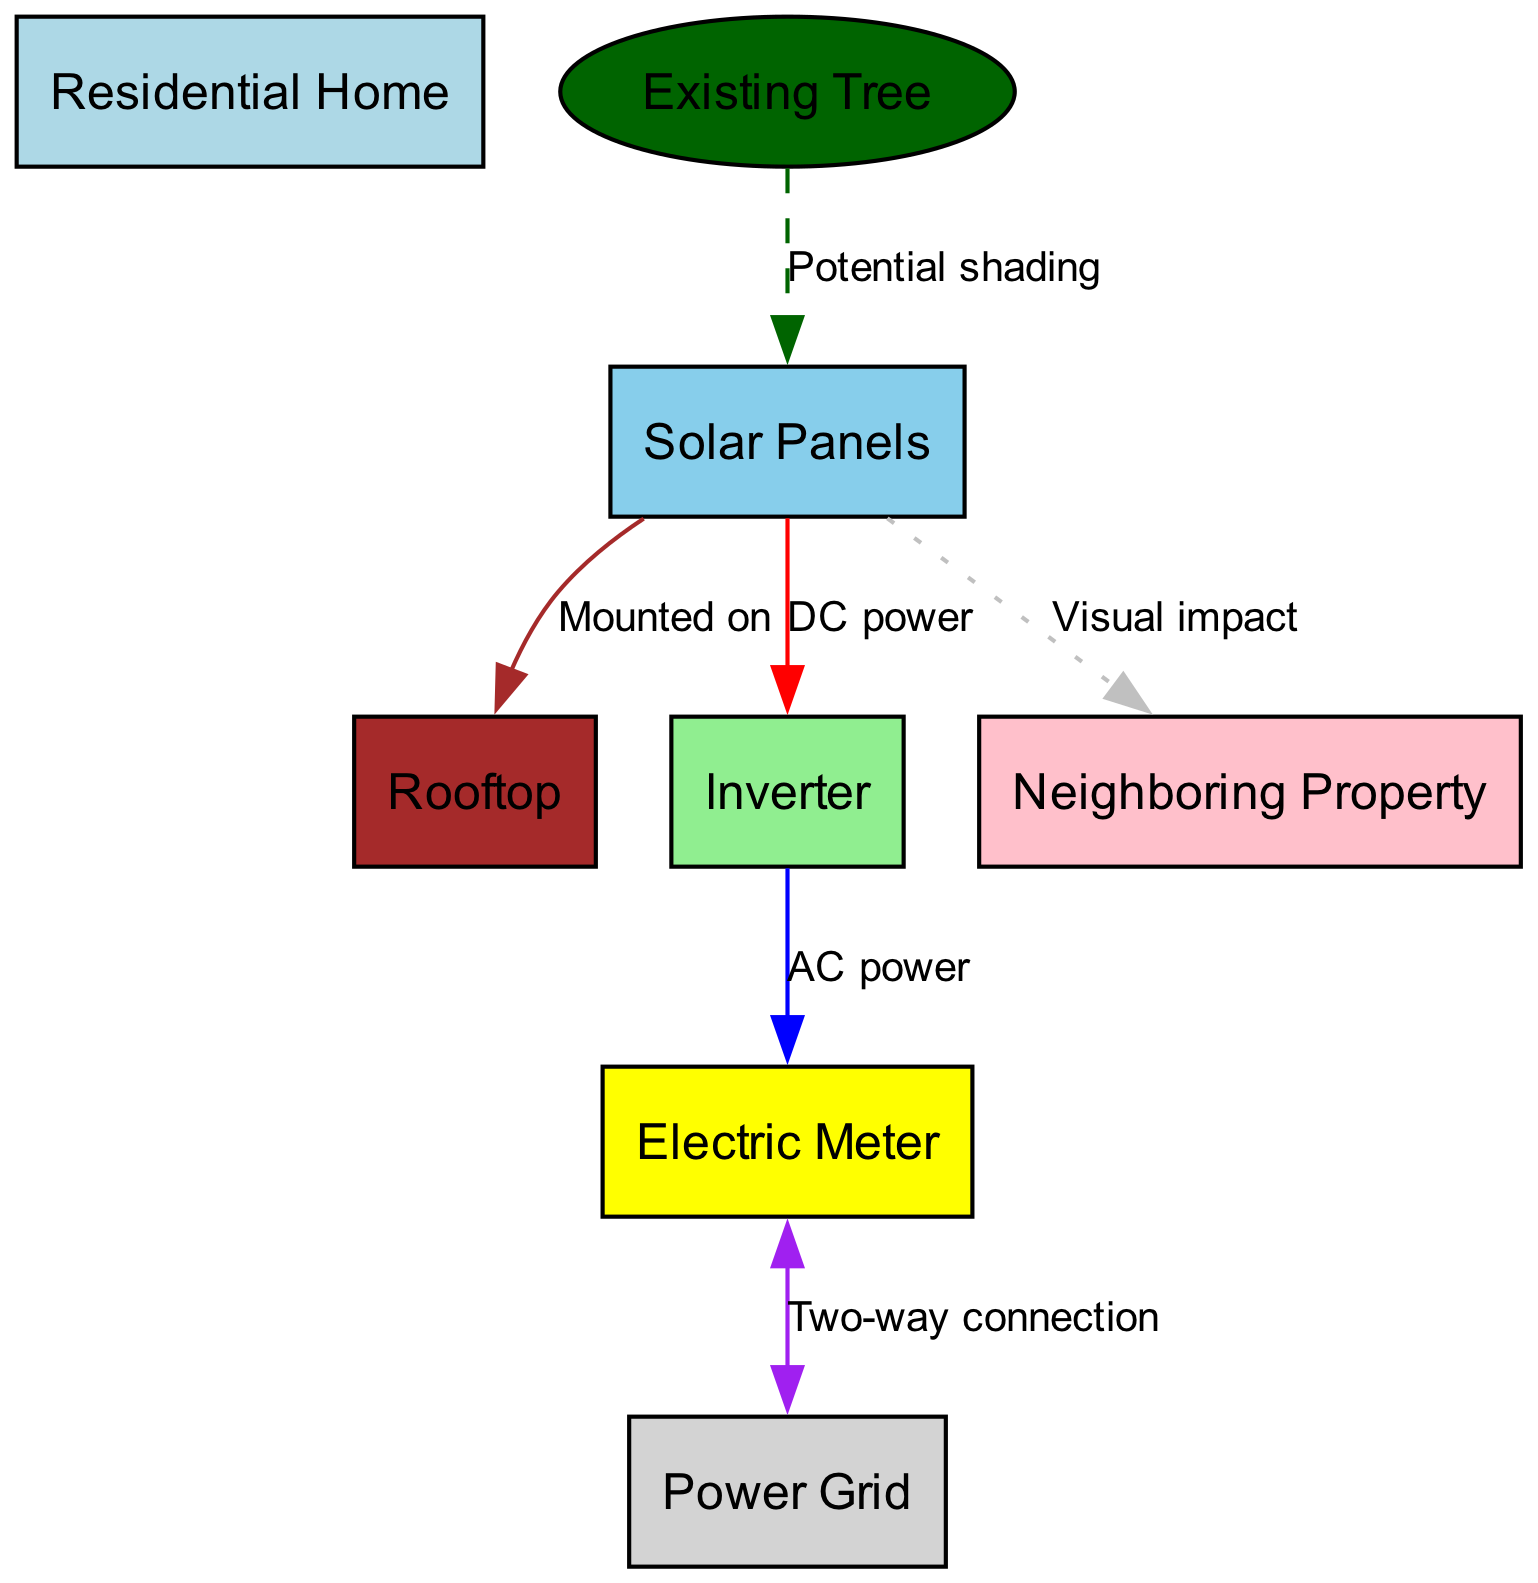What is the total number of nodes in the diagram? The diagram includes a list of nodes: Residential Home, Rooftop, Solar Panels, Inverter, Electric Meter, Power Grid, Existing Tree, and Neighboring Property. Counting these nodes results in a total of eight nodes.
Answer: 8 What is the label for the node connected to the Electric Meter? In the diagram, the Electric Meter is connected to the Power Grid according to the edge labeled as "Two-way connection". Therefore, the label for the connected node is Power Grid.
Answer: Power Grid How many types of connections are shown between the Solar Panels and other components? The Solar Panels have three different types of connections in the diagram: "Mounted on" to the Rooftop, "DC power" to the Inverter, and "Visual impact" to the Neighboring Property. Thus, there are three types of connections.
Answer: 3 What is the shading influence depicted in the diagram? The diagram illustrates the potential shading caused by the Existing Tree on the Solar Panels, as indicated by the edge labeled "Potential shading". This means that the tree can obstruct sunlight from reaching the solar panels.
Answer: Potential shading Which node represents the component that converts DC power to AC power? The component that converts DC power to AC power in the diagram is the Inverter, as denoted by the edge labeled "AC power" that connects it to the Electric Meter.
Answer: Inverter Which two nodes are linked by a dashed line? The dashed line indicates a "Potential shading" connection between the Existing Tree and the Solar Panels. This style denotes that the connection is not solid but rather conditional or not permanent.
Answer: Existing Tree and Solar Panels What aspect of property aesthetics is highlighted in the diagram? The diagram symbolizes the visual impact from the Solar Panels to the Neighboring Property through the edge labeled "Visual impact". This indicates that the presence of solar panels may affect the aesthetic perception from neighboring homes.
Answer: Visual impact What is the relationship between the Solar Panels and the Rooftop? The relationship between the Solar Panels and the Rooftop is shown as a "Mounted on" connection, meaning the solar panels are installed or placed upon the rooftop.
Answer: Mounted on 